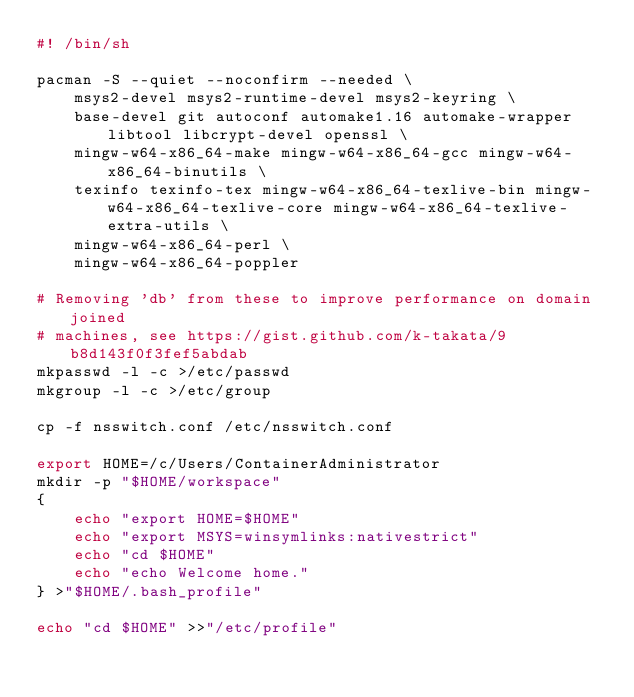<code> <loc_0><loc_0><loc_500><loc_500><_Bash_>#! /bin/sh

pacman -S --quiet --noconfirm --needed \
    msys2-devel msys2-runtime-devel msys2-keyring \
    base-devel git autoconf automake1.16 automake-wrapper libtool libcrypt-devel openssl \
    mingw-w64-x86_64-make mingw-w64-x86_64-gcc mingw-w64-x86_64-binutils \
    texinfo texinfo-tex mingw-w64-x86_64-texlive-bin mingw-w64-x86_64-texlive-core mingw-w64-x86_64-texlive-extra-utils \
    mingw-w64-x86_64-perl \
    mingw-w64-x86_64-poppler

# Removing 'db' from these to improve performance on domain joined
# machines, see https://gist.github.com/k-takata/9b8d143f0f3fef5abdab
mkpasswd -l -c >/etc/passwd
mkgroup -l -c >/etc/group

cp -f nsswitch.conf /etc/nsswitch.conf

export HOME=/c/Users/ContainerAdministrator
mkdir -p "$HOME/workspace"
{
    echo "export HOME=$HOME"
    echo "export MSYS=winsymlinks:nativestrict"
    echo "cd $HOME"
    echo "echo Welcome home."
} >"$HOME/.bash_profile"

echo "cd $HOME" >>"/etc/profile"
</code> 